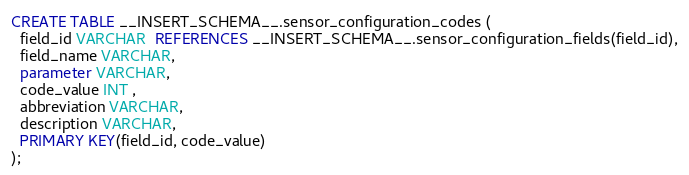<code> <loc_0><loc_0><loc_500><loc_500><_SQL_>CREATE TABLE __INSERT_SCHEMA__.sensor_configuration_codes (
  field_id VARCHAR  REFERENCES __INSERT_SCHEMA__.sensor_configuration_fields(field_id),
  field_name VARCHAR,
  parameter VARCHAR,
  code_value INT ,
  abbreviation VARCHAR,
  description VARCHAR,
  PRIMARY KEY(field_id, code_value)
);
</code> 